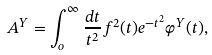Convert formula to latex. <formula><loc_0><loc_0><loc_500><loc_500>A ^ { Y } = \int ^ { \infty } _ { o } \frac { d t } { t ^ { 2 } } f ^ { 2 } ( t ) e ^ { - t ^ { 2 } } \varphi ^ { Y } ( t ) ,</formula> 